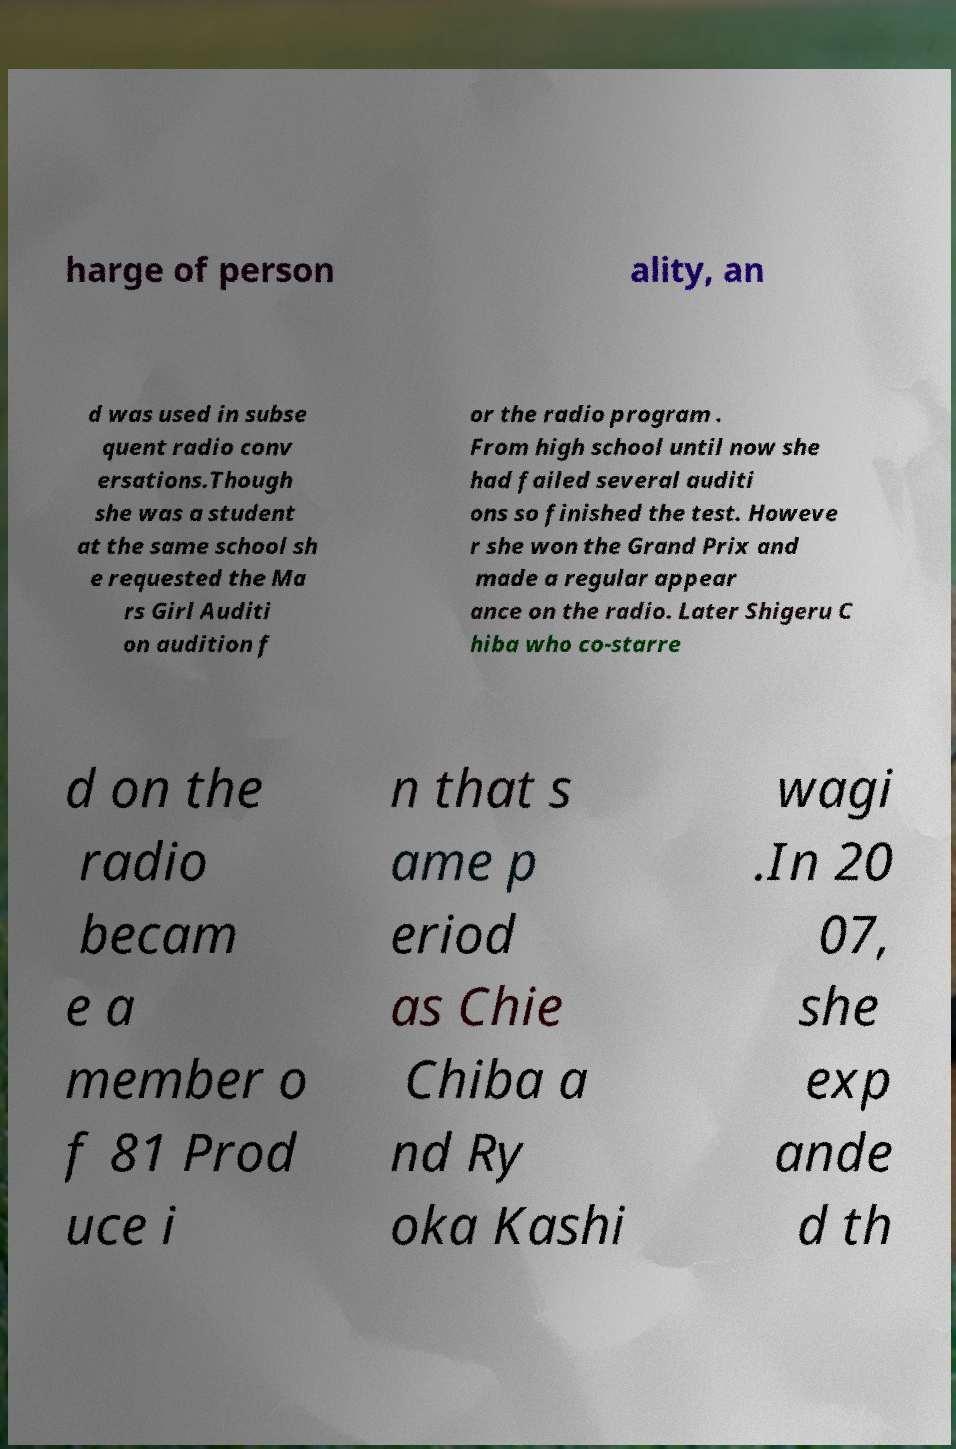Could you extract and type out the text from this image? harge of person ality, an d was used in subse quent radio conv ersations.Though she was a student at the same school sh e requested the Ma rs Girl Auditi on audition f or the radio program . From high school until now she had failed several auditi ons so finished the test. Howeve r she won the Grand Prix and made a regular appear ance on the radio. Later Shigeru C hiba who co-starre d on the radio becam e a member o f 81 Prod uce i n that s ame p eriod as Chie Chiba a nd Ry oka Kashi wagi .In 20 07, she exp ande d th 